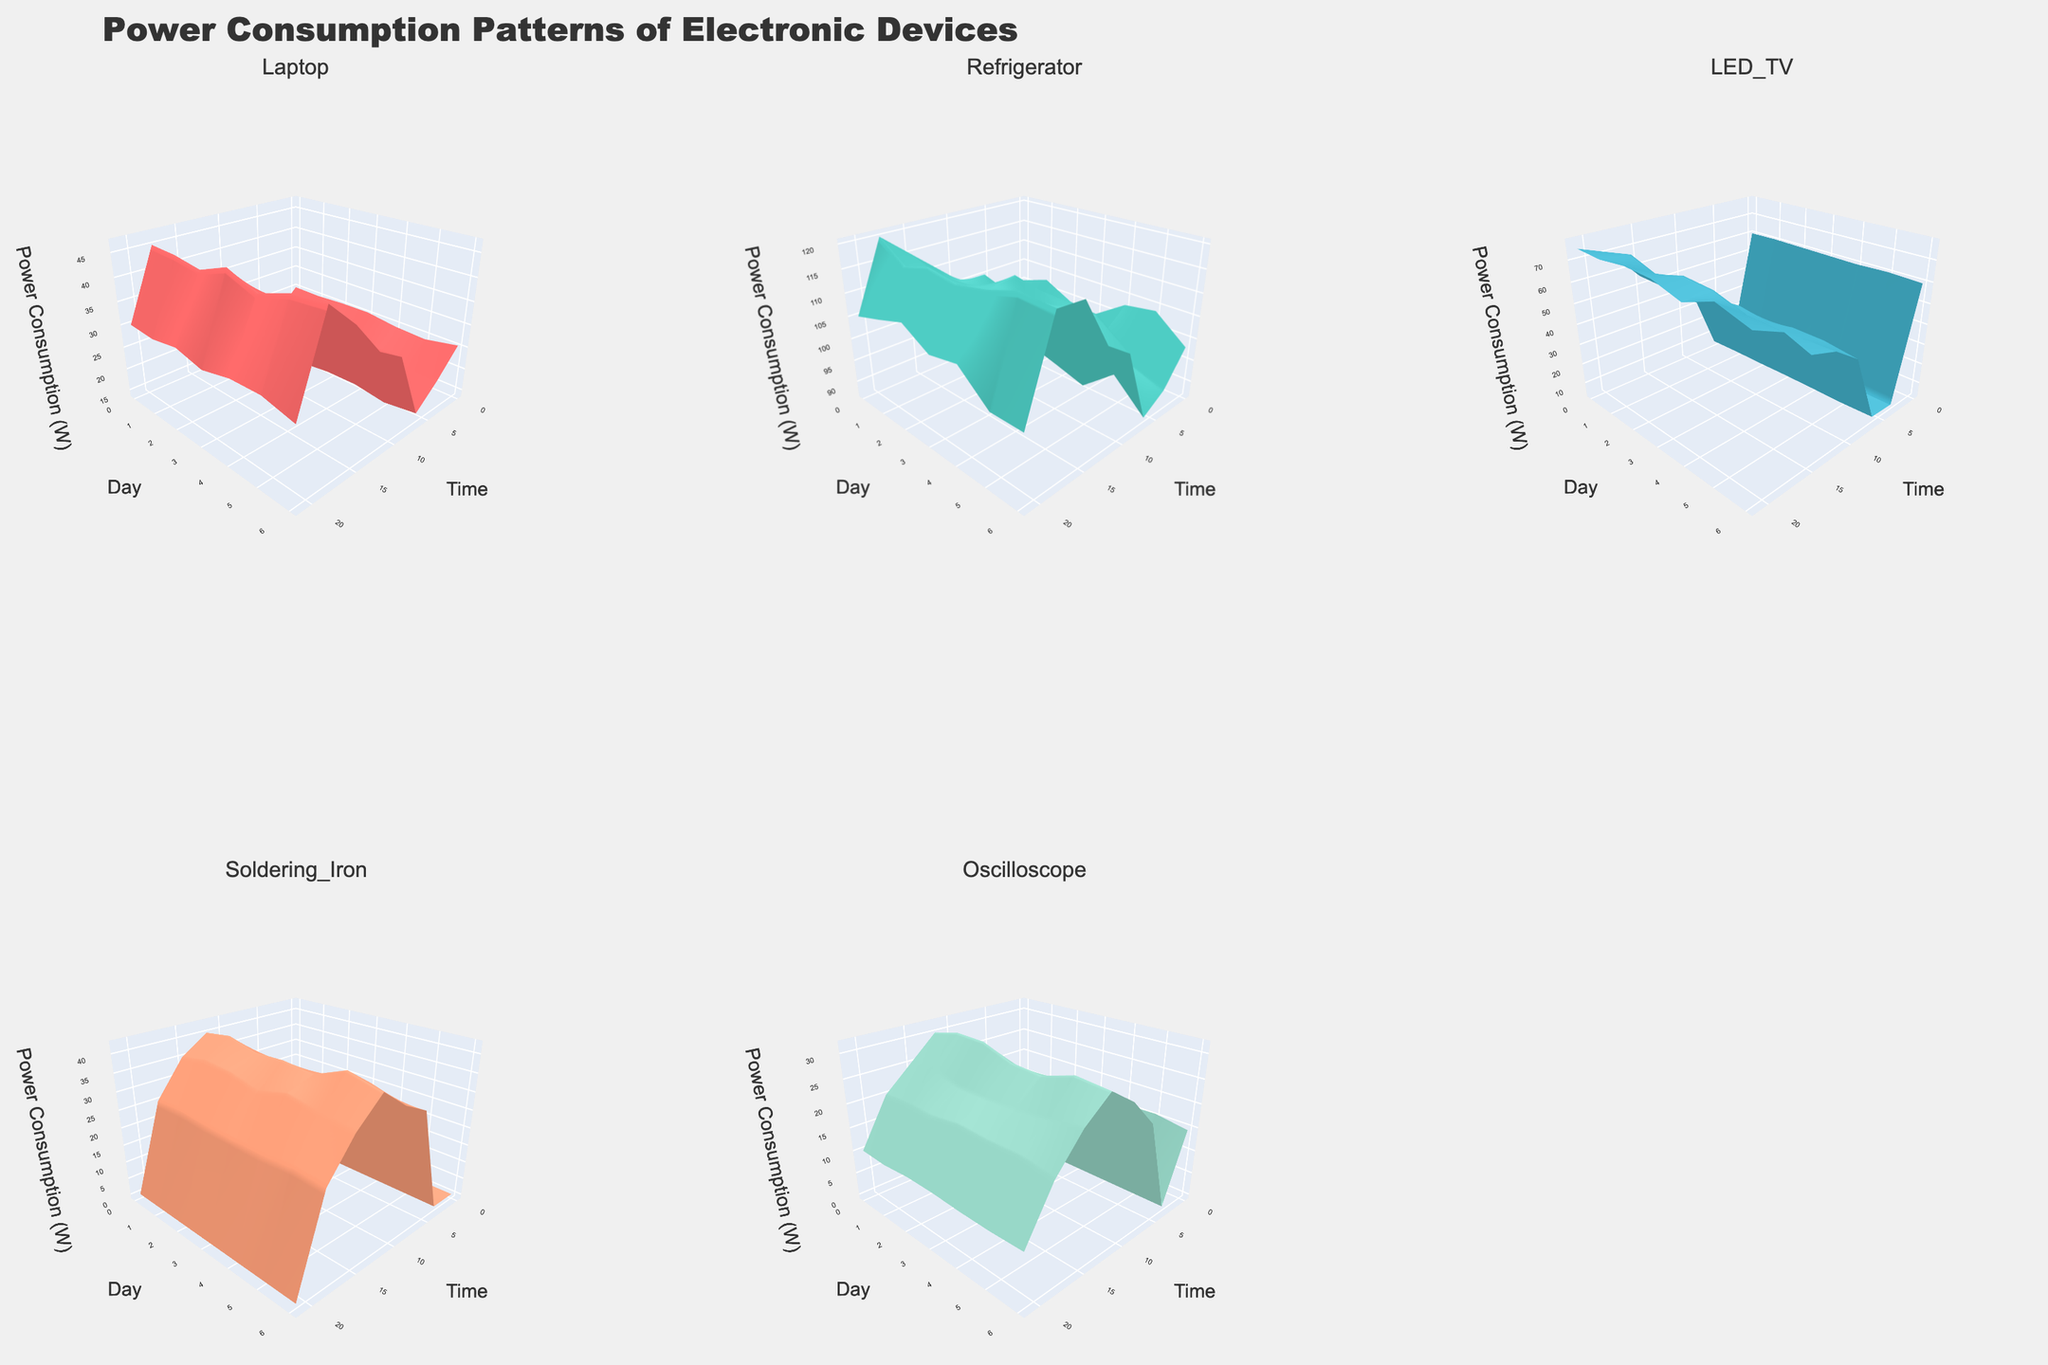what is the title of the figure? The title is written at the top of the figure and states "Power Consumption Patterns of Electronic Devices".
Answer: Power Consumption Patterns of Electronic Devices How many devices are compared in the figure? By counting the number of subplot titles or surfaces, we can identify that 5 unique devices are compared in the figure.
Answer: 5 Which device shows the highest power consumption at any time and when? Examine the surfaces and look for the highest peaks. The Refrigerator subplot shows the highest peak of around 120 watts at 18:00.
Answer: Refrigerator at 18:00 What is the general trend of LED TV's power consumption throughout the day? The curve starts high at midnight, drops to very low early in the morning, and then increases significantly throughout the day, peaking towards the evening.
Answer: Low in the morning, increases later Which device has the most consistent power consumption? The Refrigerator's surface appears relatively even compared to other devices, which indicates more consistent power consumption.
Answer: Refrigerator Compare the peak power consumption of the Laptop and the LED TV. Which one is higher and by how much? Locate the highest points in both surfaces, Laptop peaks at 45 watts and LED TV peaks at 75 watts. The LED TV has a higher peak by 30 watts.
Answer: LED TV by 30 watts What is the lowest power consumption recorded for the Oscilloscope? Check the lowest value on the Oscilloscope's surface. The minimum value is 0 watts at 3:00 and 21:00.
Answer: 0 watts What is the combined power consumption of the Soldering Iron and Oscilloscope at noon? Soldering Iron consumes 40 watts and Oscilloscope consumes 30 watts at noon (12:00). Adding these gives a combined consumption of 70 watts.
Answer: 70 watts During the afternoon (15:00 to 18:00), which device shows the fastest increase in power consumption? By examining the surfaces during this time interval, the Refrigerator shows the fastest increase from 115 watts at 15:00 to 120 watts at 18:00.
Answer: Refrigerator 